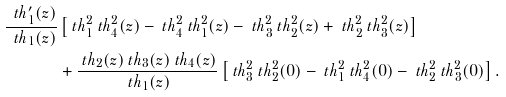Convert formula to latex. <formula><loc_0><loc_0><loc_500><loc_500>\frac { \ t h _ { 1 } ^ { \prime } ( z ) } { \ t h _ { 1 } ( z ) } & \left [ \ t h _ { 1 } ^ { 2 } \ t h _ { 4 } ^ { 2 } ( z ) - \ t h _ { 4 } ^ { 2 } \ t h _ { 1 } ^ { 2 } ( z ) - \ t h _ { 3 } ^ { 2 } \ t h _ { 2 } ^ { 2 } ( z ) + \ t h _ { 2 } ^ { 2 } \ t h _ { 3 } ^ { 2 } ( z ) \right ] \\ & + \frac { \ t h _ { 2 } ( z ) \ t h _ { 3 } ( z ) \ t h _ { 4 } ( z ) } { \ t h _ { 1 } ( z ) } \left [ \ t h _ { 3 } ^ { 2 } \ t h _ { 2 } ^ { 2 } ( 0 ) - \ t h _ { 1 } ^ { 2 } \ t h _ { 4 } ^ { 2 } ( 0 ) - \ t h _ { 2 } ^ { 2 } \ t h _ { 3 } ^ { 2 } ( 0 ) \right ] .</formula> 